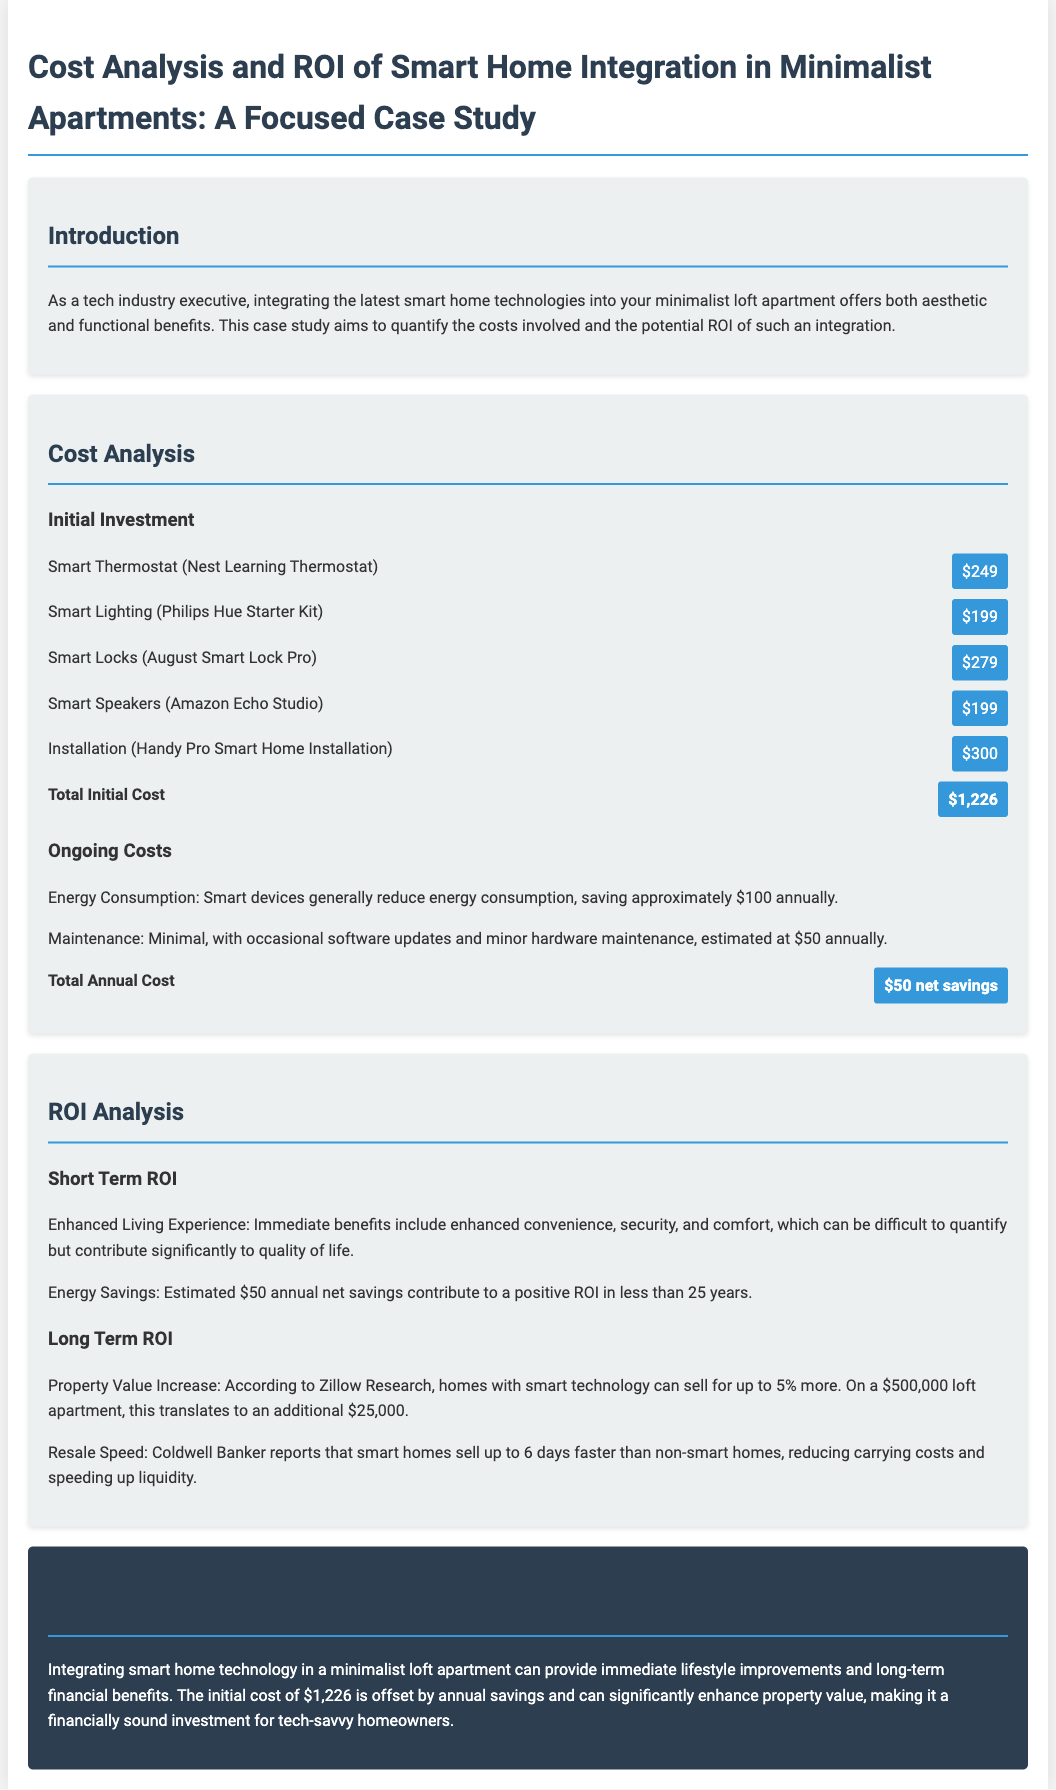What is the total initial cost of smart home integration? The total initial cost is clearly listed in the document after summing all the individual costs for devices and installation.
Answer: $1,226 What is the estimated annual savings from energy consumption? The document specifies that smart devices save approximately $100 annually, contributing to net savings.
Answer: $100 What percentage can smart homes sell for more according to Zillow Research? The document indicates that homes with smart technology can sell for up to 5% more based on Zillow Research.
Answer: 5% What is the estimated additional value for a $500,000 loft apartment with smart home technology? The document calculates the additional value based on the 5% increase for a loft priced at $500,000.
Answer: $25,000 What is the total annual cost after savings? The total annual costs include savings from energy consumption and maintenance, netting to $50 in savings.
Answer: $50 net savings What is the main conclusion about smart home integration? The conclusion summarizes the immediate benefits and long-term financial advantages of smart home technology integration.
Answer: financially sound investment What is the approximate time frame for achieving a positive ROI? The document provides insights into how long it takes for savings to offset the initial investment, which is calculated based on the annual savings.
Answer: less than 25 years What device is recommended for smart lighting? The document lists specific devices including the recommended smart lighting system.
Answer: Philips Hue Starter Kit How much can smart homes sell compared to non-smart homes according to Coldwell Banker? The document highlights the statistical difference in resale speed for smart homes as reported by Coldwell Banker.
Answer: up to 6 days faster 